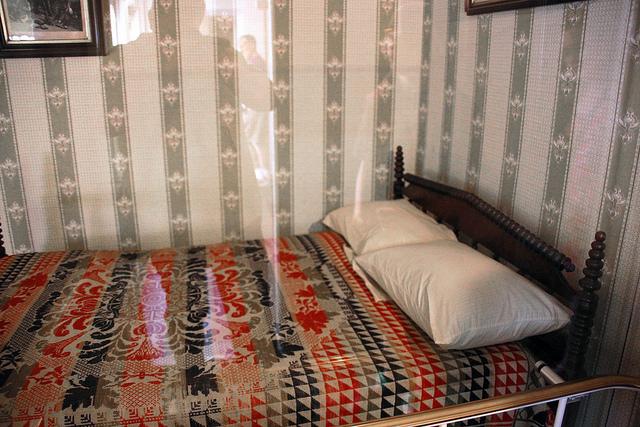Is there a sheer item in this room?
Short answer required. No. Is the bed neatly made?
Answer briefly. Yes. What direction are the stripes on the wallpaper?
Give a very brief answer. Vertical. 